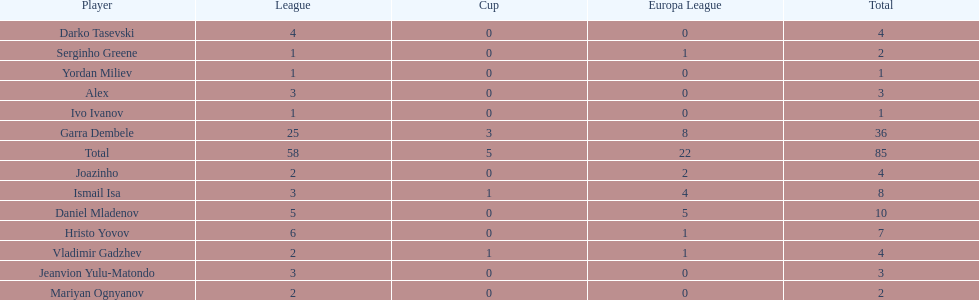What is the sum of the cup total and the europa league total? 27. 